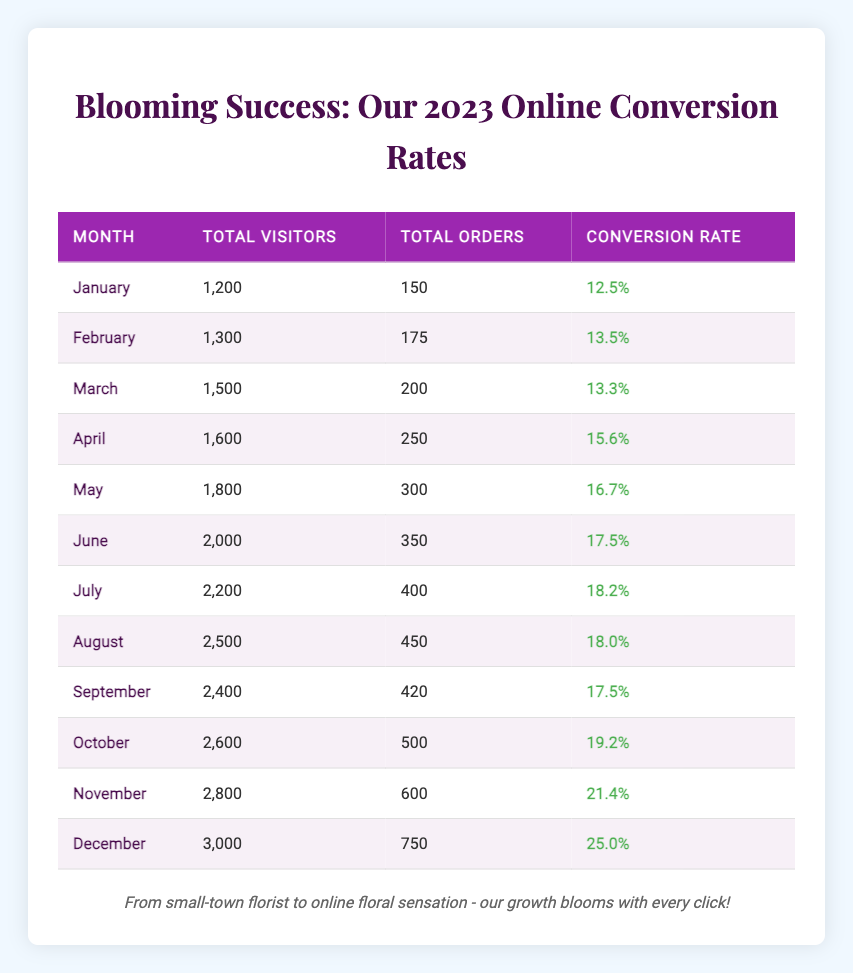What was the highest conversion rate recorded in 2023? December had the highest conversion rate at 25.0%. This is visible in the last row of the table, where the conversion rate for December is listed.
Answer: 25.0% How many orders did the business receive in November? The total orders for November can be found directly in the table, which states that there were 600 orders that month.
Answer: 600 What is the difference in conversion rates between January and June? First, find the conversion rates for both months in the table: January had a conversion rate of 12.5%, and June had a rate of 17.5%. The difference is calculated as 17.5% - 12.5% = 5%.
Answer: 5% Did the business have more than 2,000 visitors in any month? By checking the "Total Visitors" column, we can see that June, July, August, September, October, November, and December all had more than 2,000 visitors. Thus, the answer is yes.
Answer: Yes What is the average conversion rate from January to March? The conversion rates for January (12.5%), February (13.5%), and March (13.3%) need to be summed together: 12.5% + 13.5% + 13.3% = 39.3%. Then, divide by 3 months for the average: 39.3% / 3 = 13.1%.
Answer: 13.1% Which month had the second highest number of total visitors? Looking at the table, December had 3,000 visitors, the highest, followed by November with 2,800 visitors. November's visitors make it the second highest.
Answer: November How many more total orders were placed in December than in March? For December, the total orders are 750, and for March, they are 200. To find the difference: 750 - 200 = 550.
Answer: 550 Was the highest conversion rate in the last quarter of the year? The last quarter includes October, November, and December. Among these, December had the highest conversion rate of 25.0%, confirming that it was indeed the highest for that quarter.
Answer: Yes What was the total number of visitors for the first half of 2023? The visitors in the first half are: January (1200), February (1300), March (1500), April (1600), May (1800), and June (2000). Summing these gives: 1200 + 1300 + 1500 + 1600 + 1800 + 2000 = 10400.
Answer: 10400 